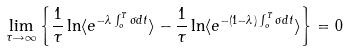Convert formula to latex. <formula><loc_0><loc_0><loc_500><loc_500>\lim _ { \tau \rightarrow \infty } \left \{ \frac { 1 } { \tau } \ln \langle e ^ { - \lambda \int _ { o } ^ { T } \sigma d t } \rangle - \frac { 1 } { \tau } \ln \langle e ^ { - ( 1 - \lambda ) \int _ { o } ^ { T } \sigma d t } \rangle \right \} = 0</formula> 